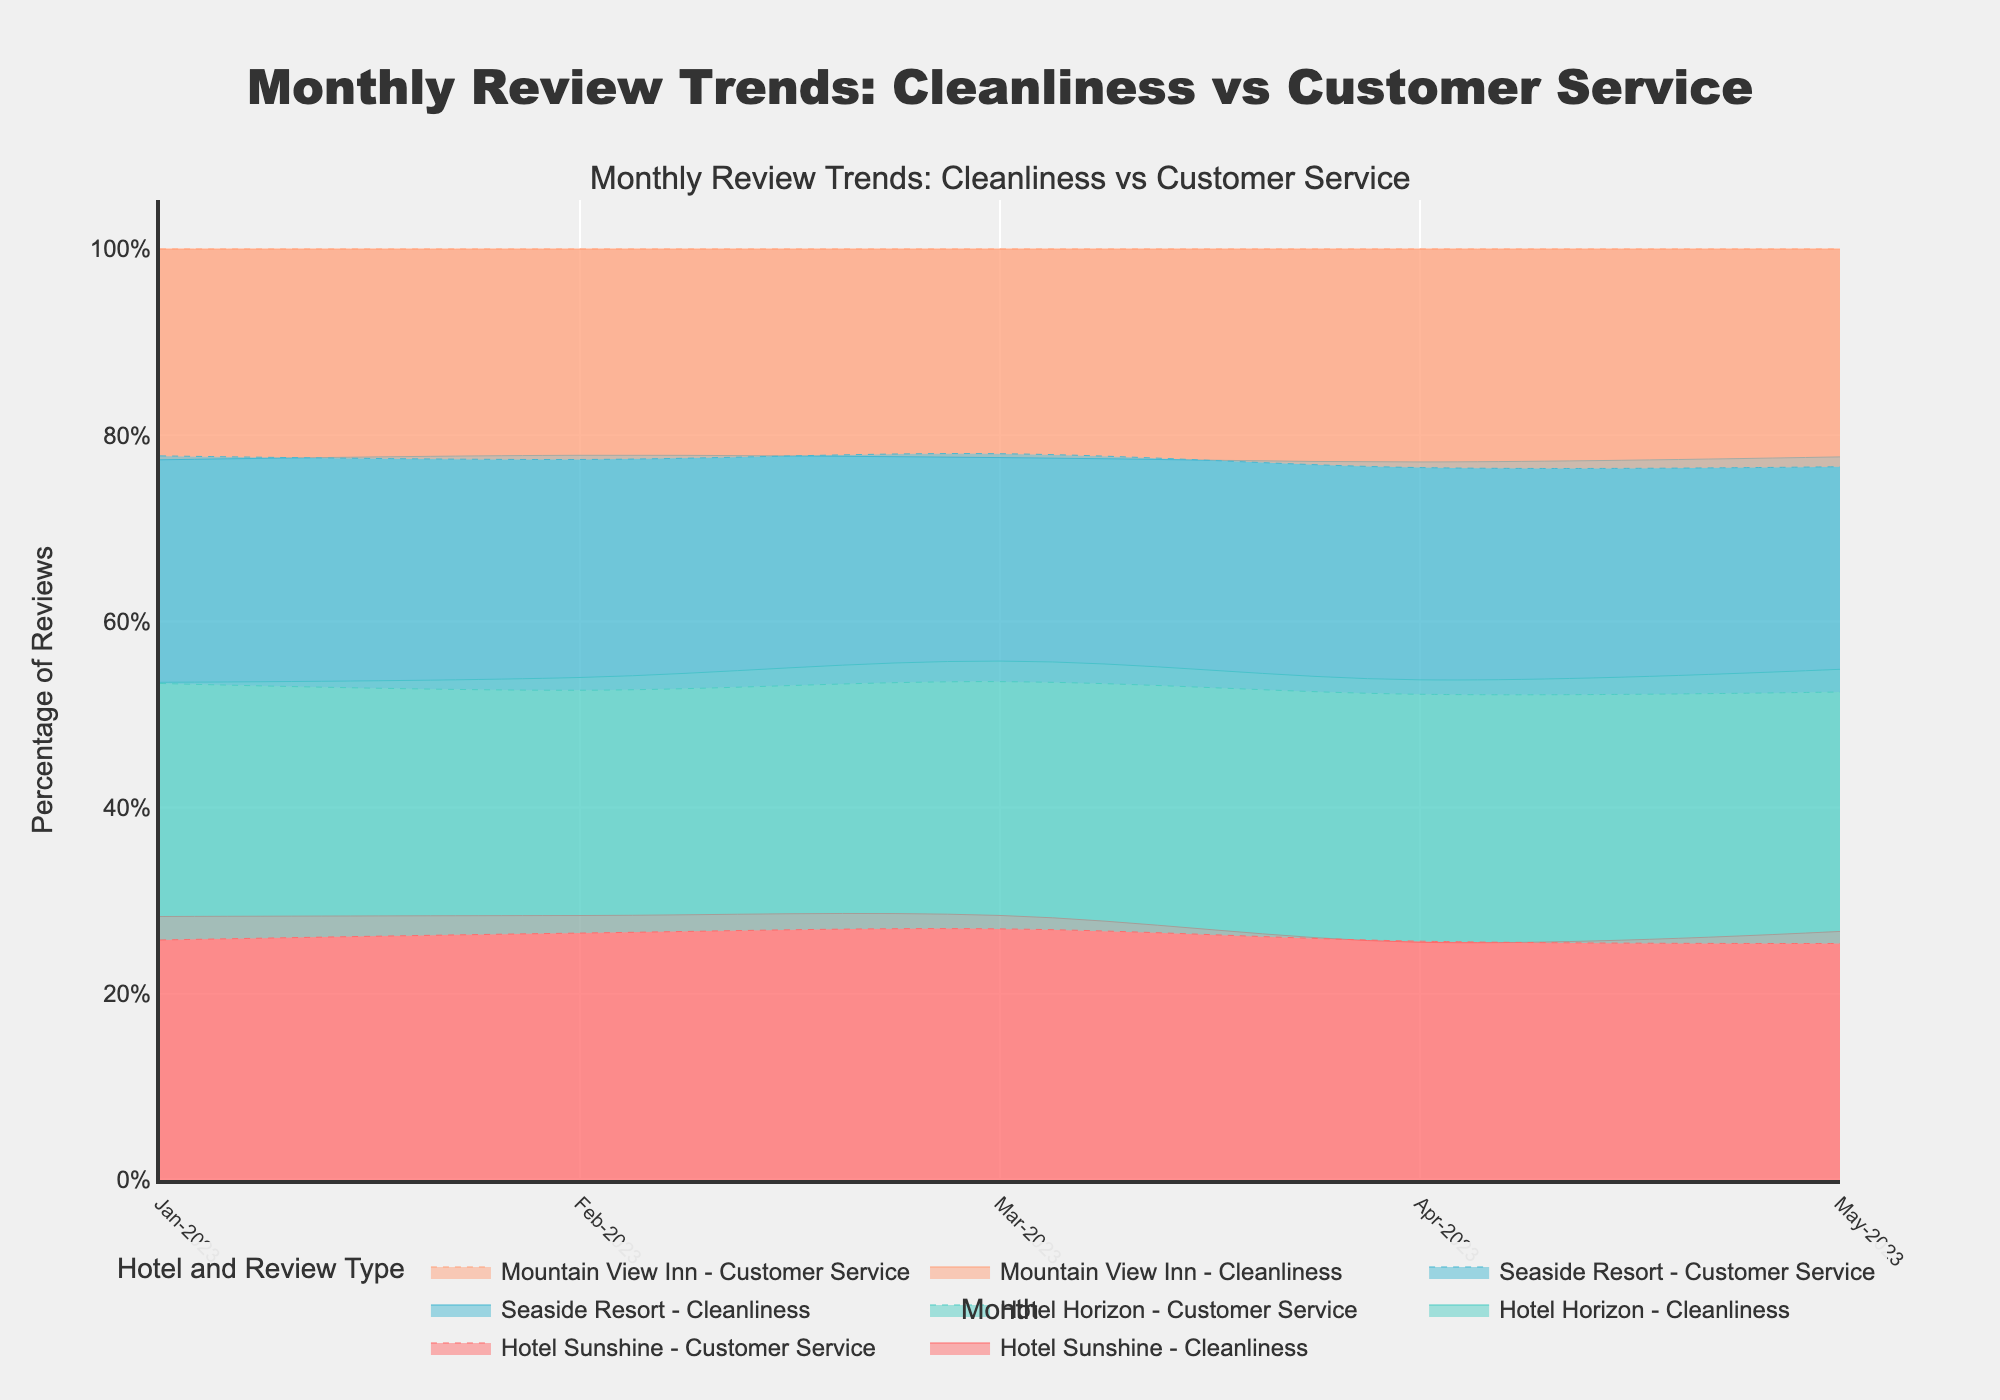What is the title of the plot? The title is usually displayed at the top center of the plot. In this case, it reads "Monthly Review Trends: Cleanliness vs Customer Service."
Answer: Monthly Review Trends: Cleanliness vs Customer Service Which hotel had the highest cleanliness reviews in May 2023? To find this, look for the highest peak in the cleanliness reviews for May 2023. According to the data, Hotel Horizon has the highest cleanliness reviews in May 2023.
Answer: Hotel Horizon How do cleanliness reviews for Seaside Resort compare from Jan-2023 to May-2023? Locate Seaside Resort in Jan-2023 and trace its cleanliness reviews across the months. In Jan-2023, the reviews are at 38, which increases to 47 by May-2023.
Answer: They increased What is the trend in customer service reviews for Hotel Sunshine from Jan-2023 to May-2023? Look for the line representing Hotel Sunshine and its customer service reviews. It starts at 58 in Jan-2023 and slightly increases to 63 in May-2023, showing a general upward trend.
Answer: Upward trend Which month had the lowest combined reviews for both cleanliness and customer service for Mountain View Inn? Sum the cleanliness and customer service reviews for Mountain View Inn for each month. Jan-2023 has the lowest combined reviews with (36+50=86).
Answer: Jan-2023 How did Hotel Horizon's customer service reviews change from Feb-2023 to Apr-2023? Locate Hotel Horizon's customer service reviews for Feb-2023 (60) and Apr-2023 (61). The reviews slightly increase from Feb-2023 to Apr-2023.
Answer: Slightly increased What is the percentage difference in cleanliness reviews between Hotel Sunshine and Mountain View Inn in May-2023? Compare the cleanliness reviews for May-2023: Hotel Sunshine (55) and Mountain View Inn (46). The percentage difference is ((55-46)/55) * 100 = 16.36%.
Answer: 16.36% Which hotel shows the most consistent customer service reviews over the months? Check the lines representing customer service reviews and identify which line is the flattest and varies the least. Hotel Sunshine has the most consistent customer service reviews.
Answer: Hotel Sunshine Between which months did Seaside Resort experience the largest increase in cleanliness reviews? Check the increase in cleanliness reviews for Seaside Resort between successive months. Feb-2023 to May-2023 shows the largest increase (42 to 47).
Answer: Feb-2023 to May-2023 